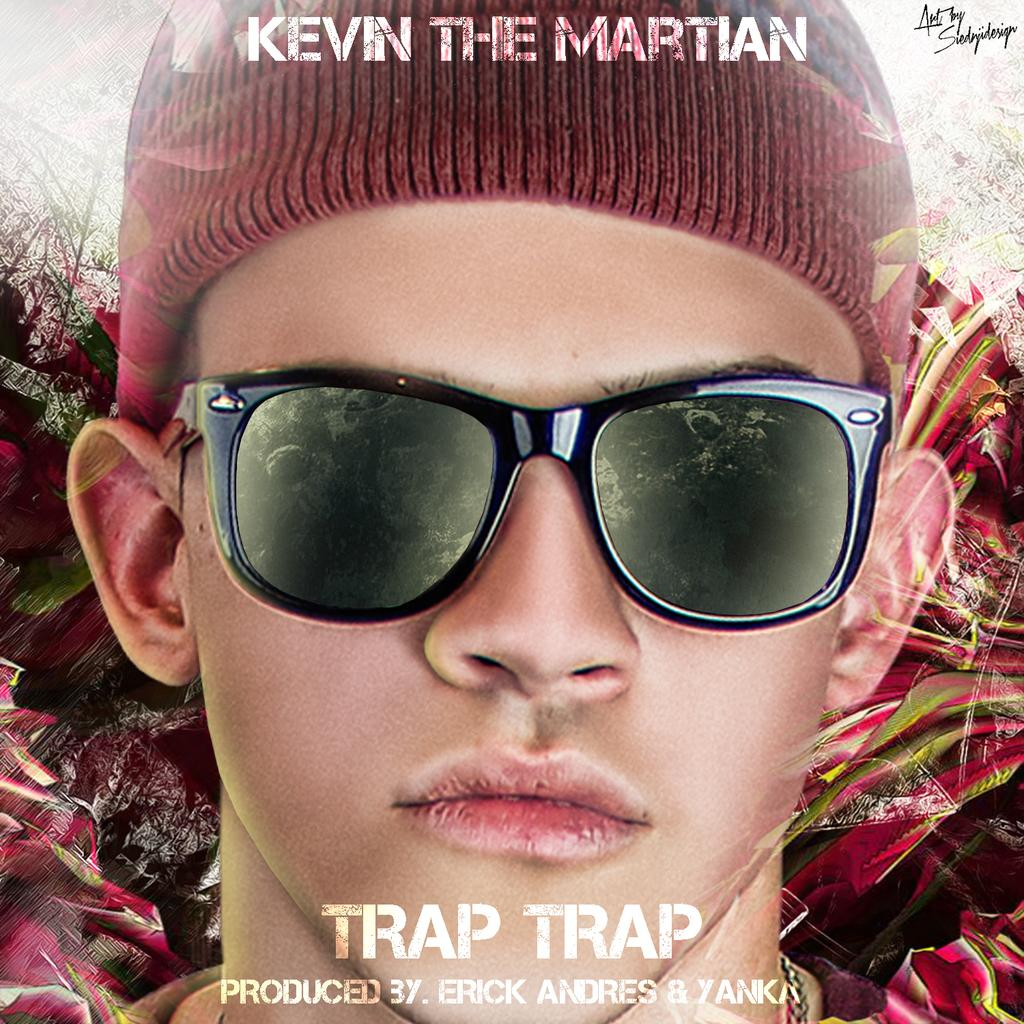<image>
Create a compact narrative representing the image presented. Ad for a song named Trap Trap by Kevin The Martian. 